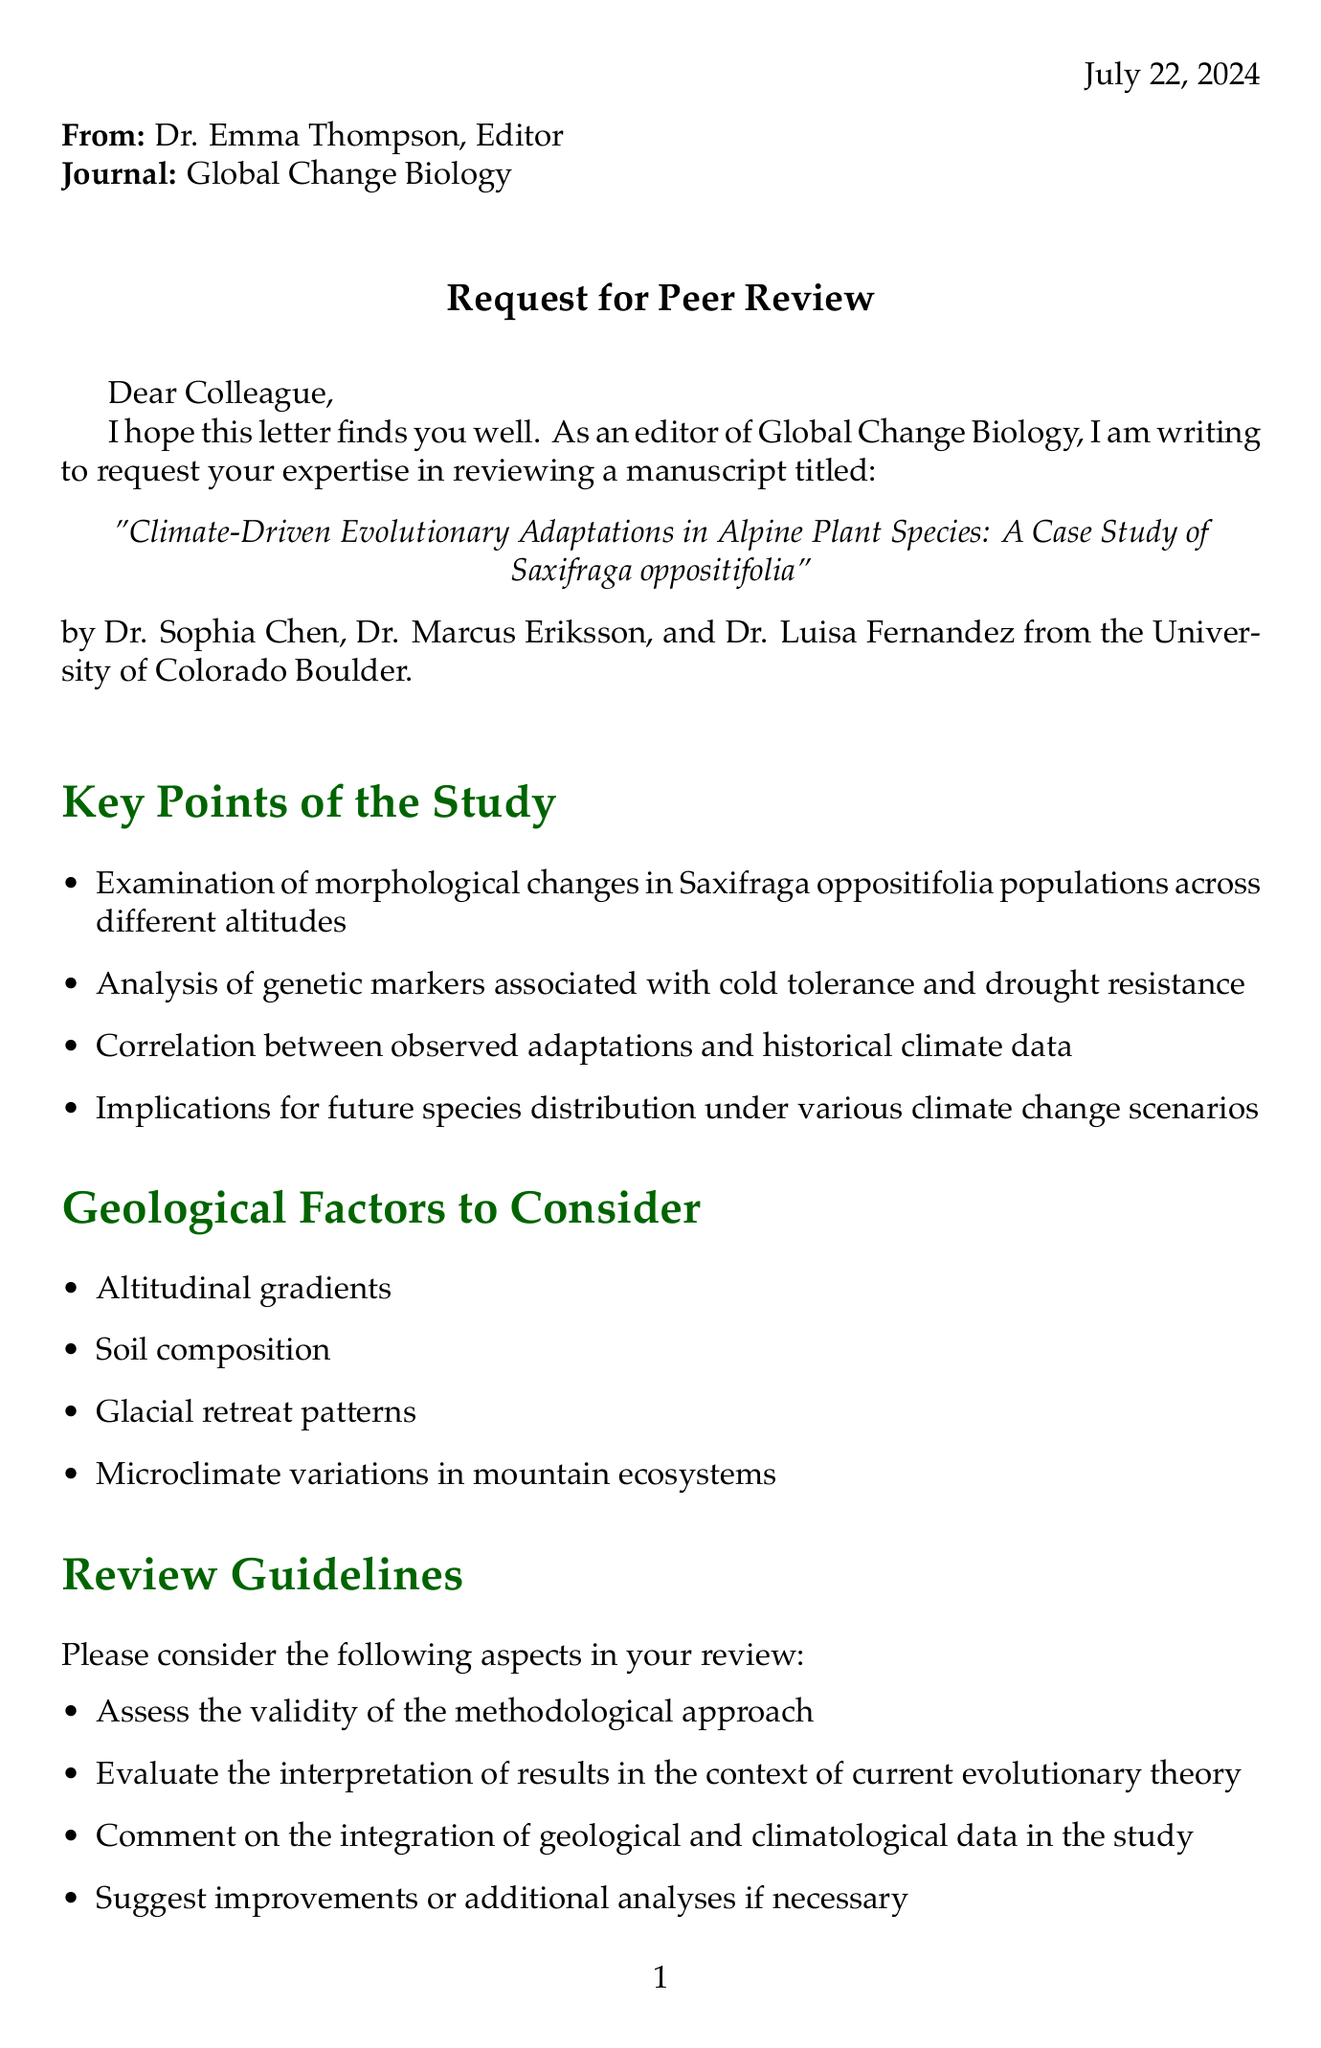What is the title of the paper? The title is stated in the letter as "Climate-Driven Evolutionary Adaptations in Alpine Plant Species: A Case Study of Saxifraga oppositifolia."
Answer: Climate-Driven Evolutionary Adaptations in Alpine Plant Species: A Case Study of Saxifraga oppositifolia Who are the authors of the manuscript? The authors listed in the document are Dr. Sophia Chen, Dr. Marcus Eriksson, and Dr. Luisa Fernandez.
Answer: Dr. Sophia Chen, Dr. Marcus Eriksson, Dr. Luisa Fernandez What is the deadline for the review? The document specifies the review deadline as June 15, 2023.
Answer: June 15, 2023 What institution are the authors affiliated with? The letter indicates that the authors are from the University of Colorado Boulder.
Answer: University of Colorado Boulder What geological factor is mentioned related to soil? One of the geological factors listed is "Soil composition."
Answer: Soil composition What is a key point regarding genetic markers in the study? It highlights the "Analysis of genetic markers associated with cold tolerance and drought resistance."
Answer: Analysis of genetic markers associated with cold tolerance and drought resistance What implications are noted for conservation strategies? The document mentions "Implications for conservation strategies in alpine environments."
Answer: Implications for conservation strategies in alpine environments What type of review is Dr. Emma Thompson requesting? The letter asks for a peer review of the manuscript.
Answer: Peer review What should be ensured regarding the manuscript's confidentiality? The document requests that the contents remain confidential and not shared with any third parties.
Answer: Remain confidential and are not shared with any third parties 